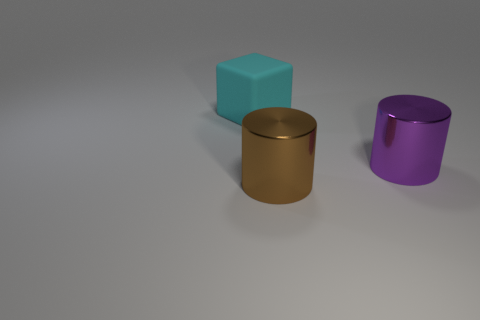Add 1 shiny things. How many objects exist? 4 Subtract all blocks. How many objects are left? 2 Add 3 big cylinders. How many big cylinders are left? 5 Add 2 big things. How many big things exist? 5 Subtract 0 yellow blocks. How many objects are left? 3 Subtract all large cyan rubber objects. Subtract all brown things. How many objects are left? 1 